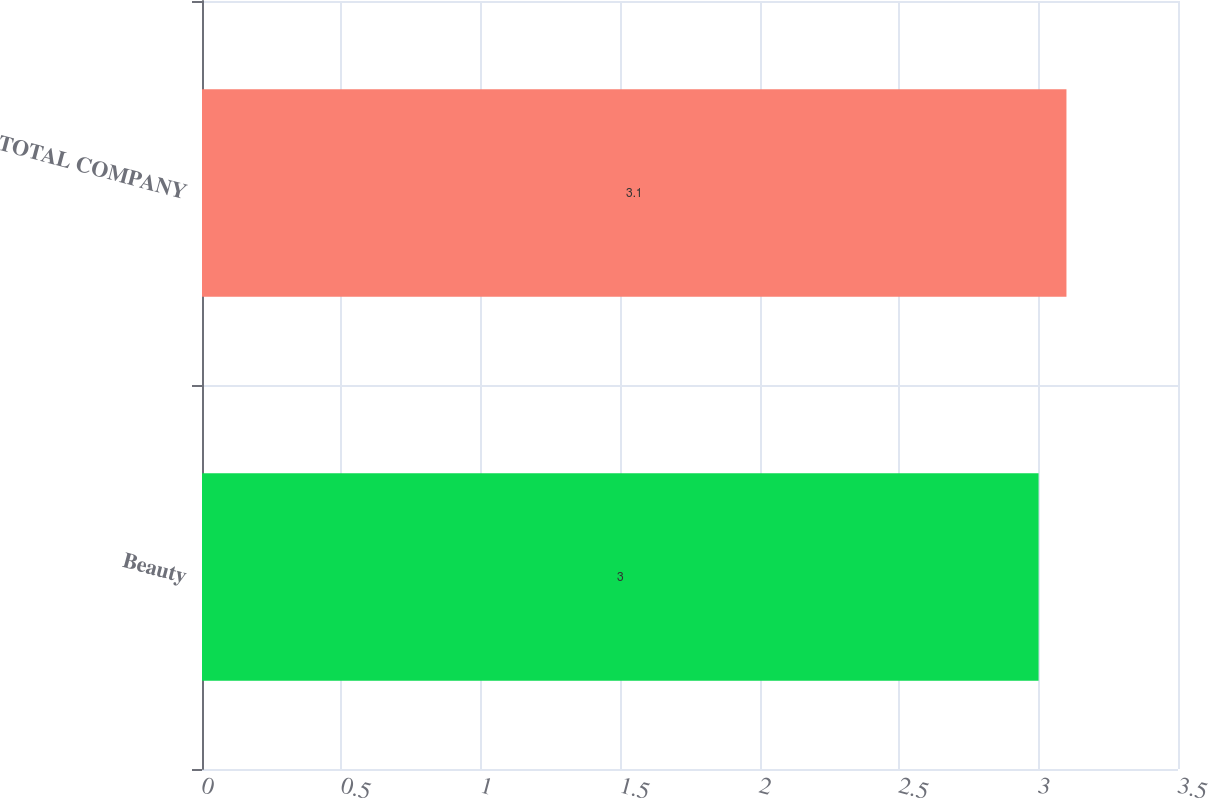Convert chart to OTSL. <chart><loc_0><loc_0><loc_500><loc_500><bar_chart><fcel>Beauty<fcel>TOTAL COMPANY<nl><fcel>3<fcel>3.1<nl></chart> 